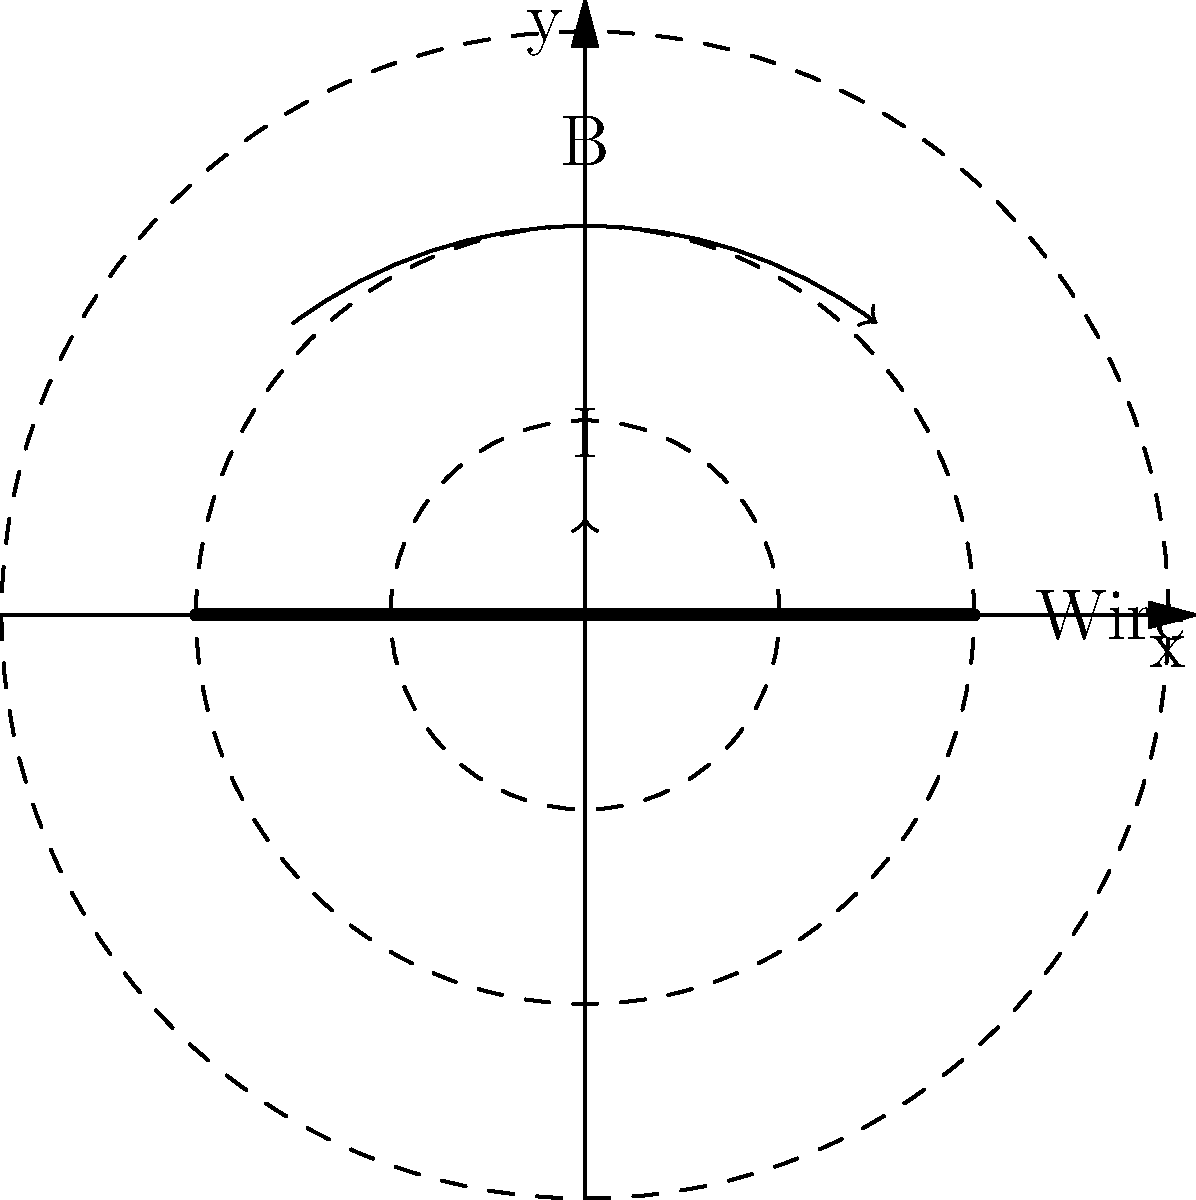In the diagram above, a current-carrying wire is shown with concentric circles representing the magnetic field lines. If the current in the wire is doubled, how will the magnetic field strength at a fixed distance from the wire change? Express your answer as a ratio of the new field strength to the original field strength. To solve this problem, let's follow these steps:

1. Recall Ampère's law for the magnetic field around a straight current-carrying wire:

   $$B = \frac{\mu_0 I}{2\pi r}$$

   Where:
   $B$ is the magnetic field strength
   $\mu_0$ is the permeability of free space (constant)
   $I$ is the current in the wire
   $r$ is the distance from the wire

2. In this case, we're doubling the current. Let's call the original current $I_1$ and the new current $I_2 = 2I_1$.

3. The original magnetic field strength:

   $$B_1 = \frac{\mu_0 I_1}{2\pi r}$$

4. The new magnetic field strength:

   $$B_2 = \frac{\mu_0 I_2}{2\pi r} = \frac{\mu_0 (2I_1)}{2\pi r}$$

5. To find the ratio of the new field strength to the original, we divide $B_2$ by $B_1$:

   $$\frac{B_2}{B_1} = \frac{\frac{\mu_0 (2I_1)}{2\pi r}}{\frac{\mu_0 I_1}{2\pi r}}$$

6. The $\mu_0$, $2\pi$, and $r$ cancel out, leaving us with:

   $$\frac{B_2}{B_1} = \frac{2I_1}{I_1} = 2$$

Therefore, when the current is doubled, the magnetic field strength at any given distance from the wire also doubles.
Answer: 2:1 